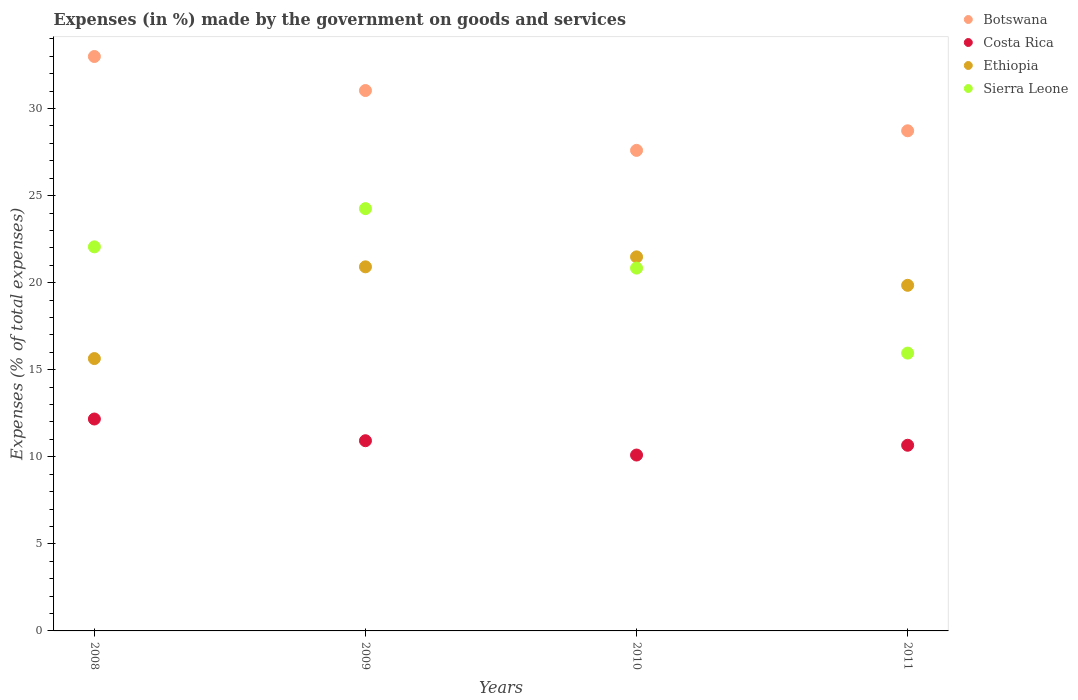How many different coloured dotlines are there?
Provide a short and direct response. 4. What is the percentage of expenses made by the government on goods and services in Costa Rica in 2009?
Make the answer very short. 10.92. Across all years, what is the maximum percentage of expenses made by the government on goods and services in Ethiopia?
Make the answer very short. 21.48. Across all years, what is the minimum percentage of expenses made by the government on goods and services in Costa Rica?
Make the answer very short. 10.1. What is the total percentage of expenses made by the government on goods and services in Ethiopia in the graph?
Provide a short and direct response. 77.88. What is the difference between the percentage of expenses made by the government on goods and services in Ethiopia in 2008 and that in 2009?
Make the answer very short. -5.27. What is the difference between the percentage of expenses made by the government on goods and services in Costa Rica in 2009 and the percentage of expenses made by the government on goods and services in Ethiopia in 2010?
Provide a short and direct response. -10.56. What is the average percentage of expenses made by the government on goods and services in Ethiopia per year?
Provide a short and direct response. 19.47. In the year 2011, what is the difference between the percentage of expenses made by the government on goods and services in Botswana and percentage of expenses made by the government on goods and services in Costa Rica?
Offer a terse response. 18.06. What is the ratio of the percentage of expenses made by the government on goods and services in Botswana in 2008 to that in 2009?
Ensure brevity in your answer.  1.06. What is the difference between the highest and the second highest percentage of expenses made by the government on goods and services in Costa Rica?
Provide a short and direct response. 1.25. What is the difference between the highest and the lowest percentage of expenses made by the government on goods and services in Sierra Leone?
Give a very brief answer. 8.3. Is it the case that in every year, the sum of the percentage of expenses made by the government on goods and services in Sierra Leone and percentage of expenses made by the government on goods and services in Costa Rica  is greater than the sum of percentage of expenses made by the government on goods and services in Ethiopia and percentage of expenses made by the government on goods and services in Botswana?
Give a very brief answer. Yes. Is it the case that in every year, the sum of the percentage of expenses made by the government on goods and services in Sierra Leone and percentage of expenses made by the government on goods and services in Ethiopia  is greater than the percentage of expenses made by the government on goods and services in Botswana?
Make the answer very short. Yes. Does the percentage of expenses made by the government on goods and services in Botswana monotonically increase over the years?
Your answer should be very brief. No. Is the percentage of expenses made by the government on goods and services in Costa Rica strictly greater than the percentage of expenses made by the government on goods and services in Botswana over the years?
Make the answer very short. No. Is the percentage of expenses made by the government on goods and services in Botswana strictly less than the percentage of expenses made by the government on goods and services in Ethiopia over the years?
Your response must be concise. No. Are the values on the major ticks of Y-axis written in scientific E-notation?
Provide a short and direct response. No. Where does the legend appear in the graph?
Your answer should be compact. Top right. How many legend labels are there?
Give a very brief answer. 4. How are the legend labels stacked?
Keep it short and to the point. Vertical. What is the title of the graph?
Your response must be concise. Expenses (in %) made by the government on goods and services. What is the label or title of the Y-axis?
Make the answer very short. Expenses (% of total expenses). What is the Expenses (% of total expenses) of Botswana in 2008?
Offer a terse response. 32.99. What is the Expenses (% of total expenses) of Costa Rica in 2008?
Make the answer very short. 12.17. What is the Expenses (% of total expenses) of Ethiopia in 2008?
Your answer should be compact. 15.64. What is the Expenses (% of total expenses) of Sierra Leone in 2008?
Your answer should be compact. 22.06. What is the Expenses (% of total expenses) of Botswana in 2009?
Give a very brief answer. 31.03. What is the Expenses (% of total expenses) of Costa Rica in 2009?
Offer a terse response. 10.92. What is the Expenses (% of total expenses) in Ethiopia in 2009?
Your answer should be very brief. 20.91. What is the Expenses (% of total expenses) in Sierra Leone in 2009?
Provide a short and direct response. 24.25. What is the Expenses (% of total expenses) of Botswana in 2010?
Keep it short and to the point. 27.6. What is the Expenses (% of total expenses) of Costa Rica in 2010?
Offer a terse response. 10.1. What is the Expenses (% of total expenses) of Ethiopia in 2010?
Your answer should be very brief. 21.48. What is the Expenses (% of total expenses) of Sierra Leone in 2010?
Ensure brevity in your answer.  20.84. What is the Expenses (% of total expenses) in Botswana in 2011?
Provide a short and direct response. 28.72. What is the Expenses (% of total expenses) in Costa Rica in 2011?
Offer a very short reply. 10.66. What is the Expenses (% of total expenses) in Ethiopia in 2011?
Offer a very short reply. 19.85. What is the Expenses (% of total expenses) of Sierra Leone in 2011?
Make the answer very short. 15.95. Across all years, what is the maximum Expenses (% of total expenses) in Botswana?
Keep it short and to the point. 32.99. Across all years, what is the maximum Expenses (% of total expenses) of Costa Rica?
Provide a short and direct response. 12.17. Across all years, what is the maximum Expenses (% of total expenses) of Ethiopia?
Keep it short and to the point. 21.48. Across all years, what is the maximum Expenses (% of total expenses) in Sierra Leone?
Your answer should be very brief. 24.25. Across all years, what is the minimum Expenses (% of total expenses) of Botswana?
Give a very brief answer. 27.6. Across all years, what is the minimum Expenses (% of total expenses) in Costa Rica?
Give a very brief answer. 10.1. Across all years, what is the minimum Expenses (% of total expenses) in Ethiopia?
Give a very brief answer. 15.64. Across all years, what is the minimum Expenses (% of total expenses) in Sierra Leone?
Your answer should be compact. 15.95. What is the total Expenses (% of total expenses) in Botswana in the graph?
Provide a short and direct response. 120.34. What is the total Expenses (% of total expenses) of Costa Rica in the graph?
Provide a succinct answer. 43.86. What is the total Expenses (% of total expenses) in Ethiopia in the graph?
Your answer should be compact. 77.88. What is the total Expenses (% of total expenses) in Sierra Leone in the graph?
Your answer should be compact. 83.1. What is the difference between the Expenses (% of total expenses) of Botswana in 2008 and that in 2009?
Offer a terse response. 1.95. What is the difference between the Expenses (% of total expenses) in Costa Rica in 2008 and that in 2009?
Your response must be concise. 1.25. What is the difference between the Expenses (% of total expenses) in Ethiopia in 2008 and that in 2009?
Your answer should be compact. -5.27. What is the difference between the Expenses (% of total expenses) of Sierra Leone in 2008 and that in 2009?
Your response must be concise. -2.19. What is the difference between the Expenses (% of total expenses) in Botswana in 2008 and that in 2010?
Provide a short and direct response. 5.39. What is the difference between the Expenses (% of total expenses) of Costa Rica in 2008 and that in 2010?
Ensure brevity in your answer.  2.07. What is the difference between the Expenses (% of total expenses) in Ethiopia in 2008 and that in 2010?
Give a very brief answer. -5.84. What is the difference between the Expenses (% of total expenses) in Sierra Leone in 2008 and that in 2010?
Keep it short and to the point. 1.22. What is the difference between the Expenses (% of total expenses) of Botswana in 2008 and that in 2011?
Your response must be concise. 4.27. What is the difference between the Expenses (% of total expenses) in Costa Rica in 2008 and that in 2011?
Provide a succinct answer. 1.51. What is the difference between the Expenses (% of total expenses) of Ethiopia in 2008 and that in 2011?
Make the answer very short. -4.21. What is the difference between the Expenses (% of total expenses) in Sierra Leone in 2008 and that in 2011?
Make the answer very short. 6.1. What is the difference between the Expenses (% of total expenses) of Botswana in 2009 and that in 2010?
Offer a very short reply. 3.44. What is the difference between the Expenses (% of total expenses) in Costa Rica in 2009 and that in 2010?
Your response must be concise. 0.82. What is the difference between the Expenses (% of total expenses) in Ethiopia in 2009 and that in 2010?
Your answer should be very brief. -0.57. What is the difference between the Expenses (% of total expenses) in Sierra Leone in 2009 and that in 2010?
Make the answer very short. 3.42. What is the difference between the Expenses (% of total expenses) in Botswana in 2009 and that in 2011?
Provide a short and direct response. 2.31. What is the difference between the Expenses (% of total expenses) of Costa Rica in 2009 and that in 2011?
Offer a very short reply. 0.26. What is the difference between the Expenses (% of total expenses) in Ethiopia in 2009 and that in 2011?
Your answer should be very brief. 1.06. What is the difference between the Expenses (% of total expenses) of Sierra Leone in 2009 and that in 2011?
Your answer should be compact. 8.3. What is the difference between the Expenses (% of total expenses) of Botswana in 2010 and that in 2011?
Provide a short and direct response. -1.12. What is the difference between the Expenses (% of total expenses) of Costa Rica in 2010 and that in 2011?
Ensure brevity in your answer.  -0.56. What is the difference between the Expenses (% of total expenses) of Ethiopia in 2010 and that in 2011?
Offer a terse response. 1.63. What is the difference between the Expenses (% of total expenses) in Sierra Leone in 2010 and that in 2011?
Give a very brief answer. 4.88. What is the difference between the Expenses (% of total expenses) in Botswana in 2008 and the Expenses (% of total expenses) in Costa Rica in 2009?
Your answer should be very brief. 22.06. What is the difference between the Expenses (% of total expenses) in Botswana in 2008 and the Expenses (% of total expenses) in Ethiopia in 2009?
Your response must be concise. 12.08. What is the difference between the Expenses (% of total expenses) in Botswana in 2008 and the Expenses (% of total expenses) in Sierra Leone in 2009?
Your answer should be very brief. 8.74. What is the difference between the Expenses (% of total expenses) in Costa Rica in 2008 and the Expenses (% of total expenses) in Ethiopia in 2009?
Your answer should be compact. -8.74. What is the difference between the Expenses (% of total expenses) in Costa Rica in 2008 and the Expenses (% of total expenses) in Sierra Leone in 2009?
Your answer should be very brief. -12.08. What is the difference between the Expenses (% of total expenses) of Ethiopia in 2008 and the Expenses (% of total expenses) of Sierra Leone in 2009?
Offer a terse response. -8.61. What is the difference between the Expenses (% of total expenses) of Botswana in 2008 and the Expenses (% of total expenses) of Costa Rica in 2010?
Provide a short and direct response. 22.89. What is the difference between the Expenses (% of total expenses) in Botswana in 2008 and the Expenses (% of total expenses) in Ethiopia in 2010?
Make the answer very short. 11.51. What is the difference between the Expenses (% of total expenses) in Botswana in 2008 and the Expenses (% of total expenses) in Sierra Leone in 2010?
Offer a very short reply. 12.15. What is the difference between the Expenses (% of total expenses) in Costa Rica in 2008 and the Expenses (% of total expenses) in Ethiopia in 2010?
Provide a succinct answer. -9.31. What is the difference between the Expenses (% of total expenses) of Costa Rica in 2008 and the Expenses (% of total expenses) of Sierra Leone in 2010?
Your answer should be compact. -8.67. What is the difference between the Expenses (% of total expenses) in Ethiopia in 2008 and the Expenses (% of total expenses) in Sierra Leone in 2010?
Keep it short and to the point. -5.19. What is the difference between the Expenses (% of total expenses) of Botswana in 2008 and the Expenses (% of total expenses) of Costa Rica in 2011?
Provide a succinct answer. 22.33. What is the difference between the Expenses (% of total expenses) in Botswana in 2008 and the Expenses (% of total expenses) in Ethiopia in 2011?
Your answer should be very brief. 13.14. What is the difference between the Expenses (% of total expenses) of Botswana in 2008 and the Expenses (% of total expenses) of Sierra Leone in 2011?
Keep it short and to the point. 17.03. What is the difference between the Expenses (% of total expenses) in Costa Rica in 2008 and the Expenses (% of total expenses) in Ethiopia in 2011?
Give a very brief answer. -7.68. What is the difference between the Expenses (% of total expenses) in Costa Rica in 2008 and the Expenses (% of total expenses) in Sierra Leone in 2011?
Your answer should be very brief. -3.79. What is the difference between the Expenses (% of total expenses) in Ethiopia in 2008 and the Expenses (% of total expenses) in Sierra Leone in 2011?
Your answer should be very brief. -0.31. What is the difference between the Expenses (% of total expenses) of Botswana in 2009 and the Expenses (% of total expenses) of Costa Rica in 2010?
Provide a short and direct response. 20.93. What is the difference between the Expenses (% of total expenses) in Botswana in 2009 and the Expenses (% of total expenses) in Ethiopia in 2010?
Make the answer very short. 9.55. What is the difference between the Expenses (% of total expenses) in Botswana in 2009 and the Expenses (% of total expenses) in Sierra Leone in 2010?
Offer a terse response. 10.2. What is the difference between the Expenses (% of total expenses) of Costa Rica in 2009 and the Expenses (% of total expenses) of Ethiopia in 2010?
Give a very brief answer. -10.56. What is the difference between the Expenses (% of total expenses) in Costa Rica in 2009 and the Expenses (% of total expenses) in Sierra Leone in 2010?
Provide a succinct answer. -9.91. What is the difference between the Expenses (% of total expenses) in Ethiopia in 2009 and the Expenses (% of total expenses) in Sierra Leone in 2010?
Your answer should be compact. 0.07. What is the difference between the Expenses (% of total expenses) in Botswana in 2009 and the Expenses (% of total expenses) in Costa Rica in 2011?
Provide a short and direct response. 20.37. What is the difference between the Expenses (% of total expenses) of Botswana in 2009 and the Expenses (% of total expenses) of Ethiopia in 2011?
Give a very brief answer. 11.19. What is the difference between the Expenses (% of total expenses) of Botswana in 2009 and the Expenses (% of total expenses) of Sierra Leone in 2011?
Provide a short and direct response. 15.08. What is the difference between the Expenses (% of total expenses) in Costa Rica in 2009 and the Expenses (% of total expenses) in Ethiopia in 2011?
Offer a terse response. -8.92. What is the difference between the Expenses (% of total expenses) of Costa Rica in 2009 and the Expenses (% of total expenses) of Sierra Leone in 2011?
Provide a succinct answer. -5.03. What is the difference between the Expenses (% of total expenses) of Ethiopia in 2009 and the Expenses (% of total expenses) of Sierra Leone in 2011?
Ensure brevity in your answer.  4.95. What is the difference between the Expenses (% of total expenses) of Botswana in 2010 and the Expenses (% of total expenses) of Costa Rica in 2011?
Make the answer very short. 16.93. What is the difference between the Expenses (% of total expenses) of Botswana in 2010 and the Expenses (% of total expenses) of Ethiopia in 2011?
Offer a very short reply. 7.75. What is the difference between the Expenses (% of total expenses) of Botswana in 2010 and the Expenses (% of total expenses) of Sierra Leone in 2011?
Give a very brief answer. 11.64. What is the difference between the Expenses (% of total expenses) of Costa Rica in 2010 and the Expenses (% of total expenses) of Ethiopia in 2011?
Ensure brevity in your answer.  -9.75. What is the difference between the Expenses (% of total expenses) of Costa Rica in 2010 and the Expenses (% of total expenses) of Sierra Leone in 2011?
Your answer should be compact. -5.85. What is the difference between the Expenses (% of total expenses) in Ethiopia in 2010 and the Expenses (% of total expenses) in Sierra Leone in 2011?
Provide a succinct answer. 5.53. What is the average Expenses (% of total expenses) in Botswana per year?
Provide a short and direct response. 30.08. What is the average Expenses (% of total expenses) in Costa Rica per year?
Keep it short and to the point. 10.96. What is the average Expenses (% of total expenses) of Ethiopia per year?
Provide a succinct answer. 19.47. What is the average Expenses (% of total expenses) in Sierra Leone per year?
Keep it short and to the point. 20.77. In the year 2008, what is the difference between the Expenses (% of total expenses) of Botswana and Expenses (% of total expenses) of Costa Rica?
Your answer should be very brief. 20.82. In the year 2008, what is the difference between the Expenses (% of total expenses) in Botswana and Expenses (% of total expenses) in Ethiopia?
Provide a succinct answer. 17.35. In the year 2008, what is the difference between the Expenses (% of total expenses) in Botswana and Expenses (% of total expenses) in Sierra Leone?
Ensure brevity in your answer.  10.93. In the year 2008, what is the difference between the Expenses (% of total expenses) of Costa Rica and Expenses (% of total expenses) of Ethiopia?
Keep it short and to the point. -3.47. In the year 2008, what is the difference between the Expenses (% of total expenses) of Costa Rica and Expenses (% of total expenses) of Sierra Leone?
Your response must be concise. -9.89. In the year 2008, what is the difference between the Expenses (% of total expenses) of Ethiopia and Expenses (% of total expenses) of Sierra Leone?
Offer a terse response. -6.42. In the year 2009, what is the difference between the Expenses (% of total expenses) of Botswana and Expenses (% of total expenses) of Costa Rica?
Offer a very short reply. 20.11. In the year 2009, what is the difference between the Expenses (% of total expenses) of Botswana and Expenses (% of total expenses) of Ethiopia?
Keep it short and to the point. 10.12. In the year 2009, what is the difference between the Expenses (% of total expenses) in Botswana and Expenses (% of total expenses) in Sierra Leone?
Ensure brevity in your answer.  6.78. In the year 2009, what is the difference between the Expenses (% of total expenses) of Costa Rica and Expenses (% of total expenses) of Ethiopia?
Ensure brevity in your answer.  -9.99. In the year 2009, what is the difference between the Expenses (% of total expenses) in Costa Rica and Expenses (% of total expenses) in Sierra Leone?
Provide a succinct answer. -13.33. In the year 2009, what is the difference between the Expenses (% of total expenses) in Ethiopia and Expenses (% of total expenses) in Sierra Leone?
Give a very brief answer. -3.34. In the year 2010, what is the difference between the Expenses (% of total expenses) of Botswana and Expenses (% of total expenses) of Costa Rica?
Your answer should be compact. 17.5. In the year 2010, what is the difference between the Expenses (% of total expenses) in Botswana and Expenses (% of total expenses) in Ethiopia?
Give a very brief answer. 6.12. In the year 2010, what is the difference between the Expenses (% of total expenses) in Botswana and Expenses (% of total expenses) in Sierra Leone?
Your answer should be very brief. 6.76. In the year 2010, what is the difference between the Expenses (% of total expenses) of Costa Rica and Expenses (% of total expenses) of Ethiopia?
Make the answer very short. -11.38. In the year 2010, what is the difference between the Expenses (% of total expenses) in Costa Rica and Expenses (% of total expenses) in Sierra Leone?
Keep it short and to the point. -10.74. In the year 2010, what is the difference between the Expenses (% of total expenses) in Ethiopia and Expenses (% of total expenses) in Sierra Leone?
Make the answer very short. 0.65. In the year 2011, what is the difference between the Expenses (% of total expenses) of Botswana and Expenses (% of total expenses) of Costa Rica?
Give a very brief answer. 18.06. In the year 2011, what is the difference between the Expenses (% of total expenses) in Botswana and Expenses (% of total expenses) in Ethiopia?
Provide a succinct answer. 8.87. In the year 2011, what is the difference between the Expenses (% of total expenses) of Botswana and Expenses (% of total expenses) of Sierra Leone?
Your answer should be compact. 12.77. In the year 2011, what is the difference between the Expenses (% of total expenses) in Costa Rica and Expenses (% of total expenses) in Ethiopia?
Ensure brevity in your answer.  -9.19. In the year 2011, what is the difference between the Expenses (% of total expenses) in Costa Rica and Expenses (% of total expenses) in Sierra Leone?
Offer a terse response. -5.29. In the year 2011, what is the difference between the Expenses (% of total expenses) in Ethiopia and Expenses (% of total expenses) in Sierra Leone?
Give a very brief answer. 3.89. What is the ratio of the Expenses (% of total expenses) of Botswana in 2008 to that in 2009?
Your answer should be very brief. 1.06. What is the ratio of the Expenses (% of total expenses) of Costa Rica in 2008 to that in 2009?
Ensure brevity in your answer.  1.11. What is the ratio of the Expenses (% of total expenses) in Ethiopia in 2008 to that in 2009?
Give a very brief answer. 0.75. What is the ratio of the Expenses (% of total expenses) in Sierra Leone in 2008 to that in 2009?
Keep it short and to the point. 0.91. What is the ratio of the Expenses (% of total expenses) in Botswana in 2008 to that in 2010?
Ensure brevity in your answer.  1.2. What is the ratio of the Expenses (% of total expenses) of Costa Rica in 2008 to that in 2010?
Provide a short and direct response. 1.2. What is the ratio of the Expenses (% of total expenses) in Ethiopia in 2008 to that in 2010?
Make the answer very short. 0.73. What is the ratio of the Expenses (% of total expenses) in Sierra Leone in 2008 to that in 2010?
Your answer should be very brief. 1.06. What is the ratio of the Expenses (% of total expenses) of Botswana in 2008 to that in 2011?
Provide a short and direct response. 1.15. What is the ratio of the Expenses (% of total expenses) of Costa Rica in 2008 to that in 2011?
Give a very brief answer. 1.14. What is the ratio of the Expenses (% of total expenses) of Ethiopia in 2008 to that in 2011?
Provide a succinct answer. 0.79. What is the ratio of the Expenses (% of total expenses) in Sierra Leone in 2008 to that in 2011?
Your answer should be compact. 1.38. What is the ratio of the Expenses (% of total expenses) in Botswana in 2009 to that in 2010?
Your response must be concise. 1.12. What is the ratio of the Expenses (% of total expenses) of Costa Rica in 2009 to that in 2010?
Offer a terse response. 1.08. What is the ratio of the Expenses (% of total expenses) in Ethiopia in 2009 to that in 2010?
Give a very brief answer. 0.97. What is the ratio of the Expenses (% of total expenses) of Sierra Leone in 2009 to that in 2010?
Your answer should be very brief. 1.16. What is the ratio of the Expenses (% of total expenses) in Botswana in 2009 to that in 2011?
Make the answer very short. 1.08. What is the ratio of the Expenses (% of total expenses) of Costa Rica in 2009 to that in 2011?
Offer a very short reply. 1.02. What is the ratio of the Expenses (% of total expenses) in Ethiopia in 2009 to that in 2011?
Keep it short and to the point. 1.05. What is the ratio of the Expenses (% of total expenses) in Sierra Leone in 2009 to that in 2011?
Make the answer very short. 1.52. What is the ratio of the Expenses (% of total expenses) of Botswana in 2010 to that in 2011?
Keep it short and to the point. 0.96. What is the ratio of the Expenses (% of total expenses) in Costa Rica in 2010 to that in 2011?
Ensure brevity in your answer.  0.95. What is the ratio of the Expenses (% of total expenses) in Ethiopia in 2010 to that in 2011?
Your response must be concise. 1.08. What is the ratio of the Expenses (% of total expenses) in Sierra Leone in 2010 to that in 2011?
Your response must be concise. 1.31. What is the difference between the highest and the second highest Expenses (% of total expenses) of Botswana?
Provide a short and direct response. 1.95. What is the difference between the highest and the second highest Expenses (% of total expenses) of Costa Rica?
Make the answer very short. 1.25. What is the difference between the highest and the second highest Expenses (% of total expenses) of Ethiopia?
Make the answer very short. 0.57. What is the difference between the highest and the second highest Expenses (% of total expenses) in Sierra Leone?
Offer a terse response. 2.19. What is the difference between the highest and the lowest Expenses (% of total expenses) of Botswana?
Ensure brevity in your answer.  5.39. What is the difference between the highest and the lowest Expenses (% of total expenses) of Costa Rica?
Offer a very short reply. 2.07. What is the difference between the highest and the lowest Expenses (% of total expenses) of Ethiopia?
Offer a terse response. 5.84. What is the difference between the highest and the lowest Expenses (% of total expenses) of Sierra Leone?
Give a very brief answer. 8.3. 